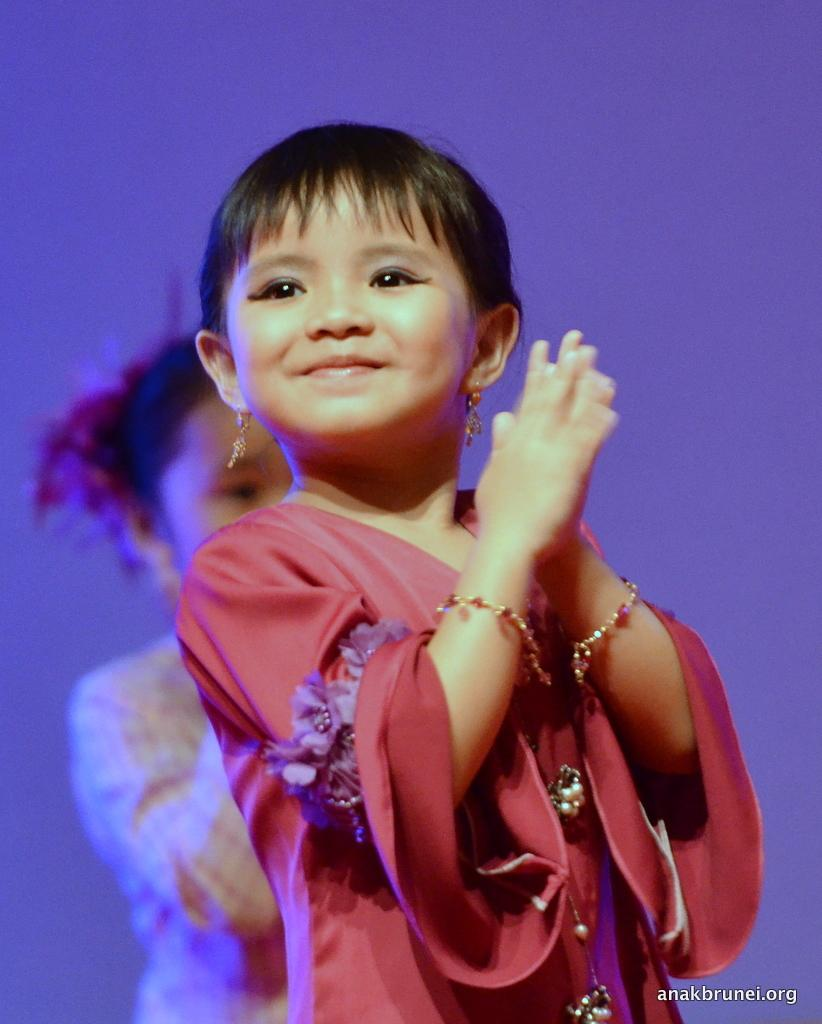Who is the main subject in the image? There is a girl in the image. What is the girl's facial expression? The girl has a smile on her face. Can you describe the positioning of the second girl in the image? There is another girl behind the first girl in the image. What type of knot is the girl tying in the image? There is no knot present in the image; the girl is simply standing with a smile on her face. 